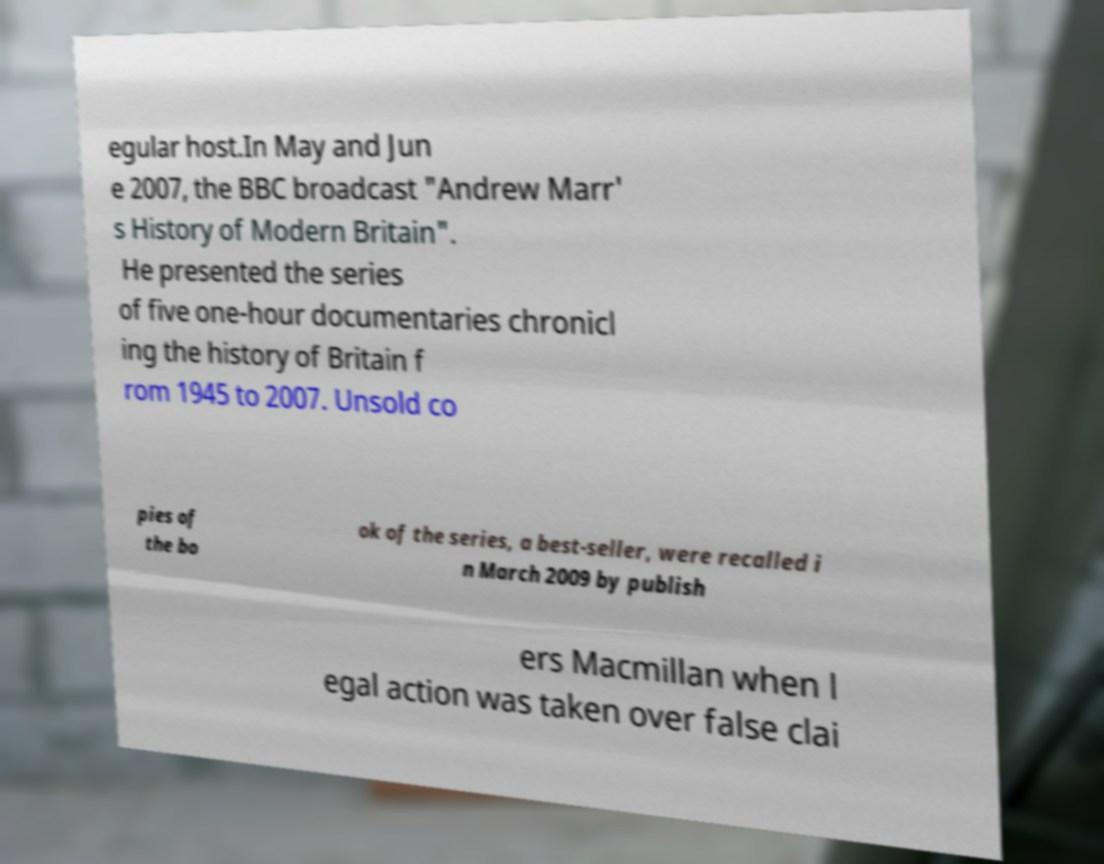For documentation purposes, I need the text within this image transcribed. Could you provide that? egular host.In May and Jun e 2007, the BBC broadcast "Andrew Marr' s History of Modern Britain". He presented the series of five one-hour documentaries chronicl ing the history of Britain f rom 1945 to 2007. Unsold co pies of the bo ok of the series, a best-seller, were recalled i n March 2009 by publish ers Macmillan when l egal action was taken over false clai 